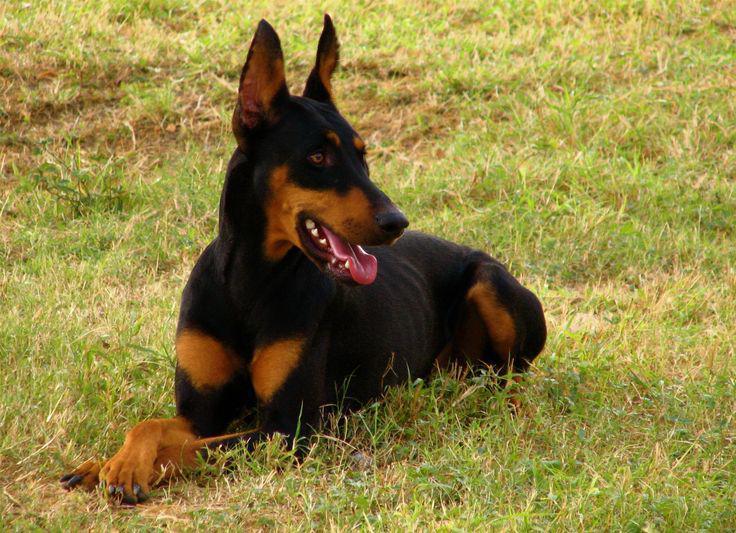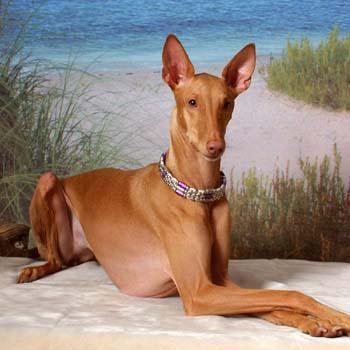The first image is the image on the left, the second image is the image on the right. Given the left and right images, does the statement "All the dogs are laying down." hold true? Answer yes or no. Yes. The first image is the image on the left, the second image is the image on the right. Considering the images on both sides, is "The left and right image contains the same number of dogs." valid? Answer yes or no. Yes. 